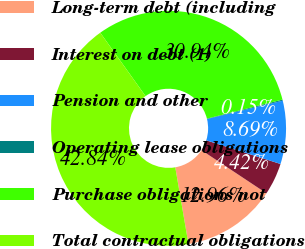Convert chart to OTSL. <chart><loc_0><loc_0><loc_500><loc_500><pie_chart><fcel>Long-term debt (including<fcel>Interest on debt (1)<fcel>Pension and other<fcel>Operating lease obligations<fcel>Purchase obligations not<fcel>Total contractual obligations<nl><fcel>12.96%<fcel>4.42%<fcel>8.69%<fcel>0.15%<fcel>30.94%<fcel>42.84%<nl></chart> 